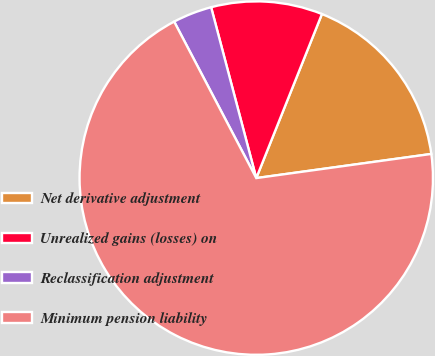<chart> <loc_0><loc_0><loc_500><loc_500><pie_chart><fcel>Net derivative adjustment<fcel>Unrealized gains (losses) on<fcel>Reclassification adjustment<fcel>Minimum pension liability<nl><fcel>16.76%<fcel>10.17%<fcel>3.58%<fcel>69.49%<nl></chart> 